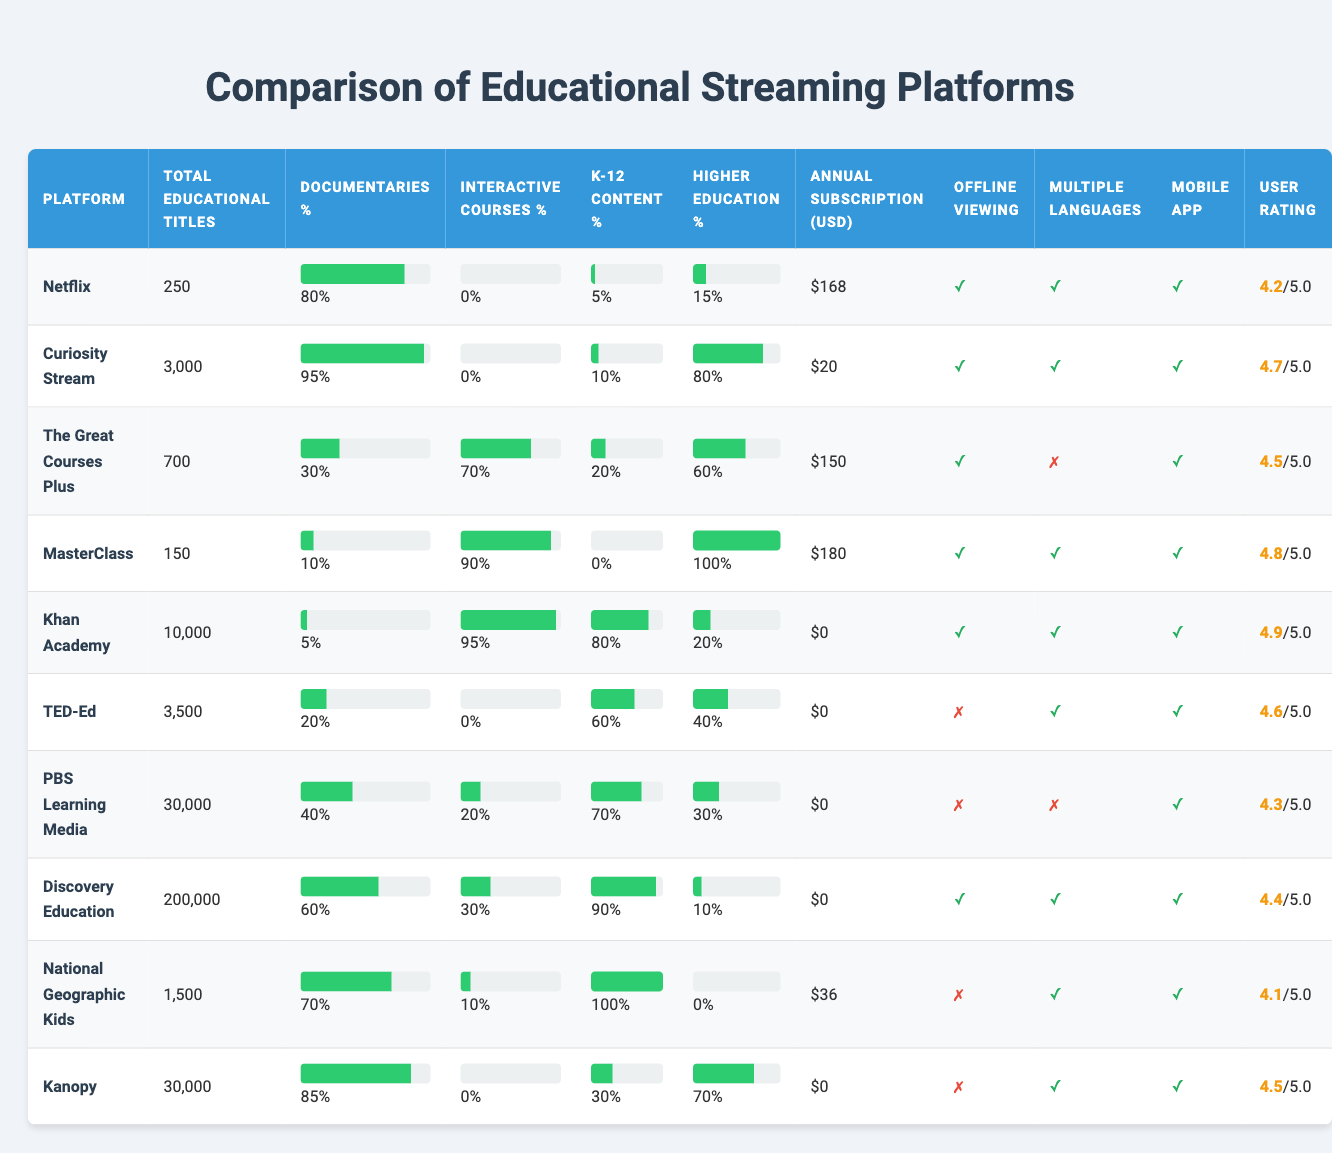What platform has the highest total educational titles? The table lists total educational titles for each platform, with PBS Learning Media having 30,000 titles, which is the highest count in the table.
Answer: PBS Learning Media Which platform has the lowest percentage of documentaries? By checking the Documentaries Percentage column, MasterClass has the lowest value at 10%.
Answer: MasterClass Is there a platform that offers free access to its educational content? In the Annual Subscription Cost USD column, Khan Academy, TED-Ed, and several others have a cost of 0, indicating they are free.
Answer: Yes Which platform has the highest percentage of K-12 content available? The K12 Content Percentage column shows that National Geographic Kids has 100% K-12 content available.
Answer: National Geographic Kids What is the average user rating of the platforms listed? To find the average, sum the ratings (4.2 + 4.7 + 4.5 + 4.8 + 4.9 + 4.6 + 4.3 + 4.4 + 4.1 + 4.5) = 46.0, then divide by the number of platforms (10): 46.0 / 10 = 4.6.
Answer: 4.6 Does Curiosity Stream provide offline viewing capabilities? The Offline Viewing column indicates that Curiosity Stream does offer offline viewing, marked by a check (✓).
Answer: Yes How much more does the most expensive platform cost compared to the cheapest? The most expensive platform is MasterClass at $180, and the cheapest is Khan Academy at $0. The difference is $180 - $0 = $180.
Answer: $180 Which two platforms have the most similar user ratings? By comparing the User Rating column, Netflix (4.2) and Kanopy (4.5) have the smallest difference of 0.3, making them the most similar in ratings.
Answer: Netflix and Kanopy Is interactive course content available on Discovery Education? The Interactive Courses Percentage for Discovery Education is 30%, so it does offer interactive content.
Answer: Yes Which platform offers the highest percentage of higher education content? In the Higher Education Content Percentage column, the highest is MasterClass with 100% of its content focused on higher education.
Answer: MasterClass 